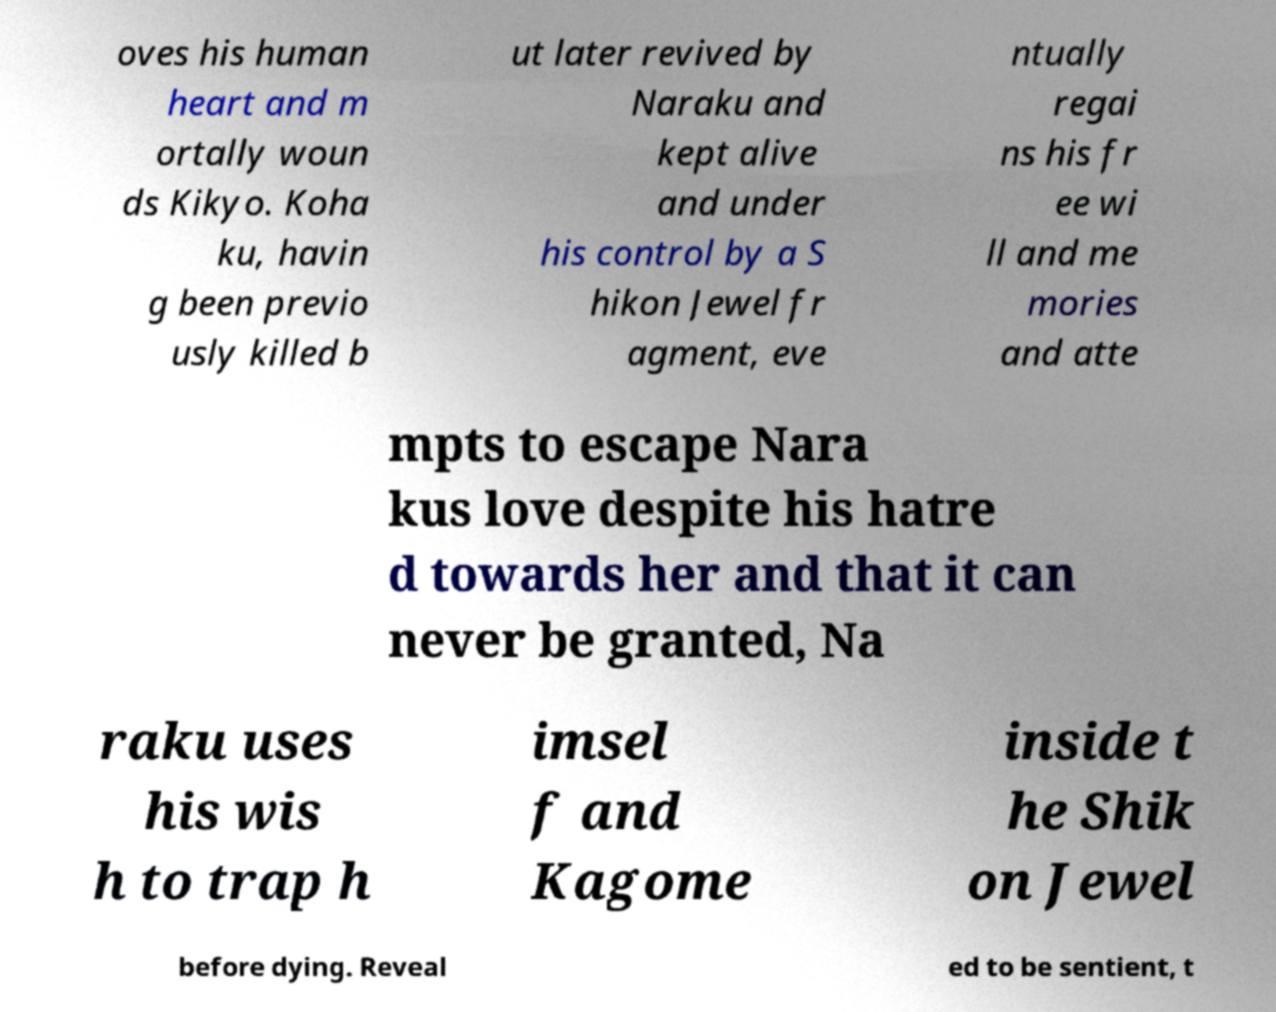What messages or text are displayed in this image? I need them in a readable, typed format. oves his human heart and m ortally woun ds Kikyo. Koha ku, havin g been previo usly killed b ut later revived by Naraku and kept alive and under his control by a S hikon Jewel fr agment, eve ntually regai ns his fr ee wi ll and me mories and atte mpts to escape Nara kus love despite his hatre d towards her and that it can never be granted, Na raku uses his wis h to trap h imsel f and Kagome inside t he Shik on Jewel before dying. Reveal ed to be sentient, t 